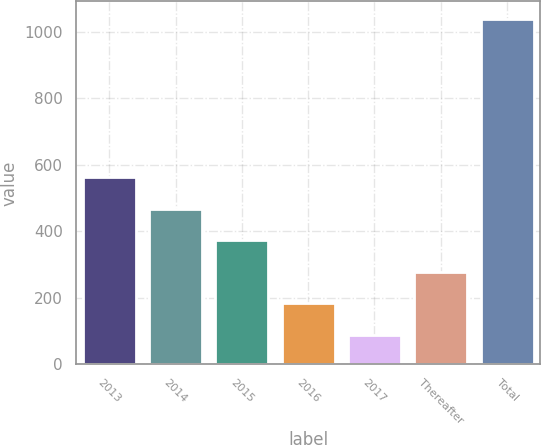Convert chart to OTSL. <chart><loc_0><loc_0><loc_500><loc_500><bar_chart><fcel>2013<fcel>2014<fcel>2015<fcel>2016<fcel>2017<fcel>Thereafter<fcel>Total<nl><fcel>564<fcel>468.8<fcel>373.6<fcel>183.2<fcel>88<fcel>278.4<fcel>1040<nl></chart> 